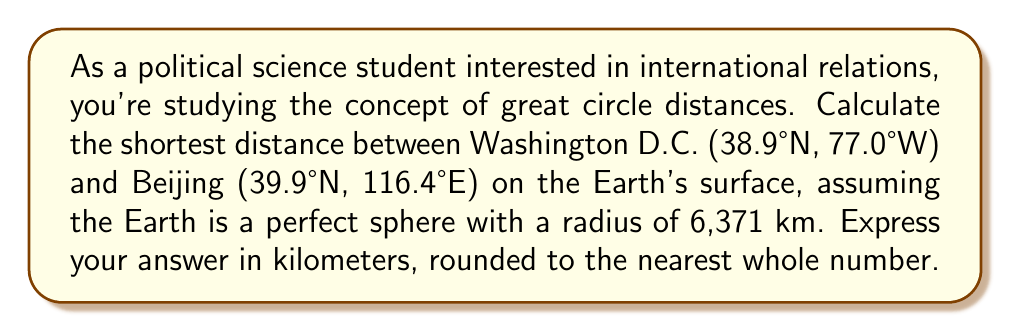Can you solve this math problem? To solve this problem, we'll use the great circle distance formula, which gives the shortest path between two points on a sphere. Here's the step-by-step solution:

1. Convert the latitudes and longitudes to radians:
   Washington D.C.: $\phi_1 = 38.9° \times \frac{\pi}{180} = 0.6790$ rad, $\lambda_1 = -77.0° \times \frac{\pi}{180} = -1.3439$ rad
   Beijing: $\phi_2 = 39.9° \times \frac{\pi}{180} = 0.6965$ rad, $\lambda_2 = 116.4° \times \frac{\pi}{180} = 2.0321$ rad

2. Calculate the central angle $\Delta\sigma$ using the Haversine formula:
   $$\Delta\sigma = 2 \arcsin\left(\sqrt{\sin^2\left(\frac{\phi_2 - \phi_1}{2}\right) + \cos\phi_1 \cos\phi_2 \sin^2\left(\frac{\lambda_2 - \lambda_1}{2}\right)}\right)$$

3. Substitute the values:
   $$\Delta\sigma = 2 \arcsin\left(\sqrt{\sin^2\left(\frac{0.6965 - 0.6790}{2}\right) + \cos(0.6790) \cos(0.6965) \sin^2\left(\frac{2.0321 - (-1.3439)}{2}\right)}\right)$$

4. Calculate the result:
   $$\Delta\sigma = 2 \arcsin(\sqrt{0.0000008 + 0.5498}) = 2 \arcsin(0.7415) = 1.6614$$ rad

5. Multiply by the Earth's radius to get the distance:
   Distance $= 6,371 \text{ km} \times 1.6614 = 10,584.37 \text{ km}$

6. Round to the nearest whole number:
   Distance $\approx 10,584 \text{ km}$
Answer: 10,584 km 